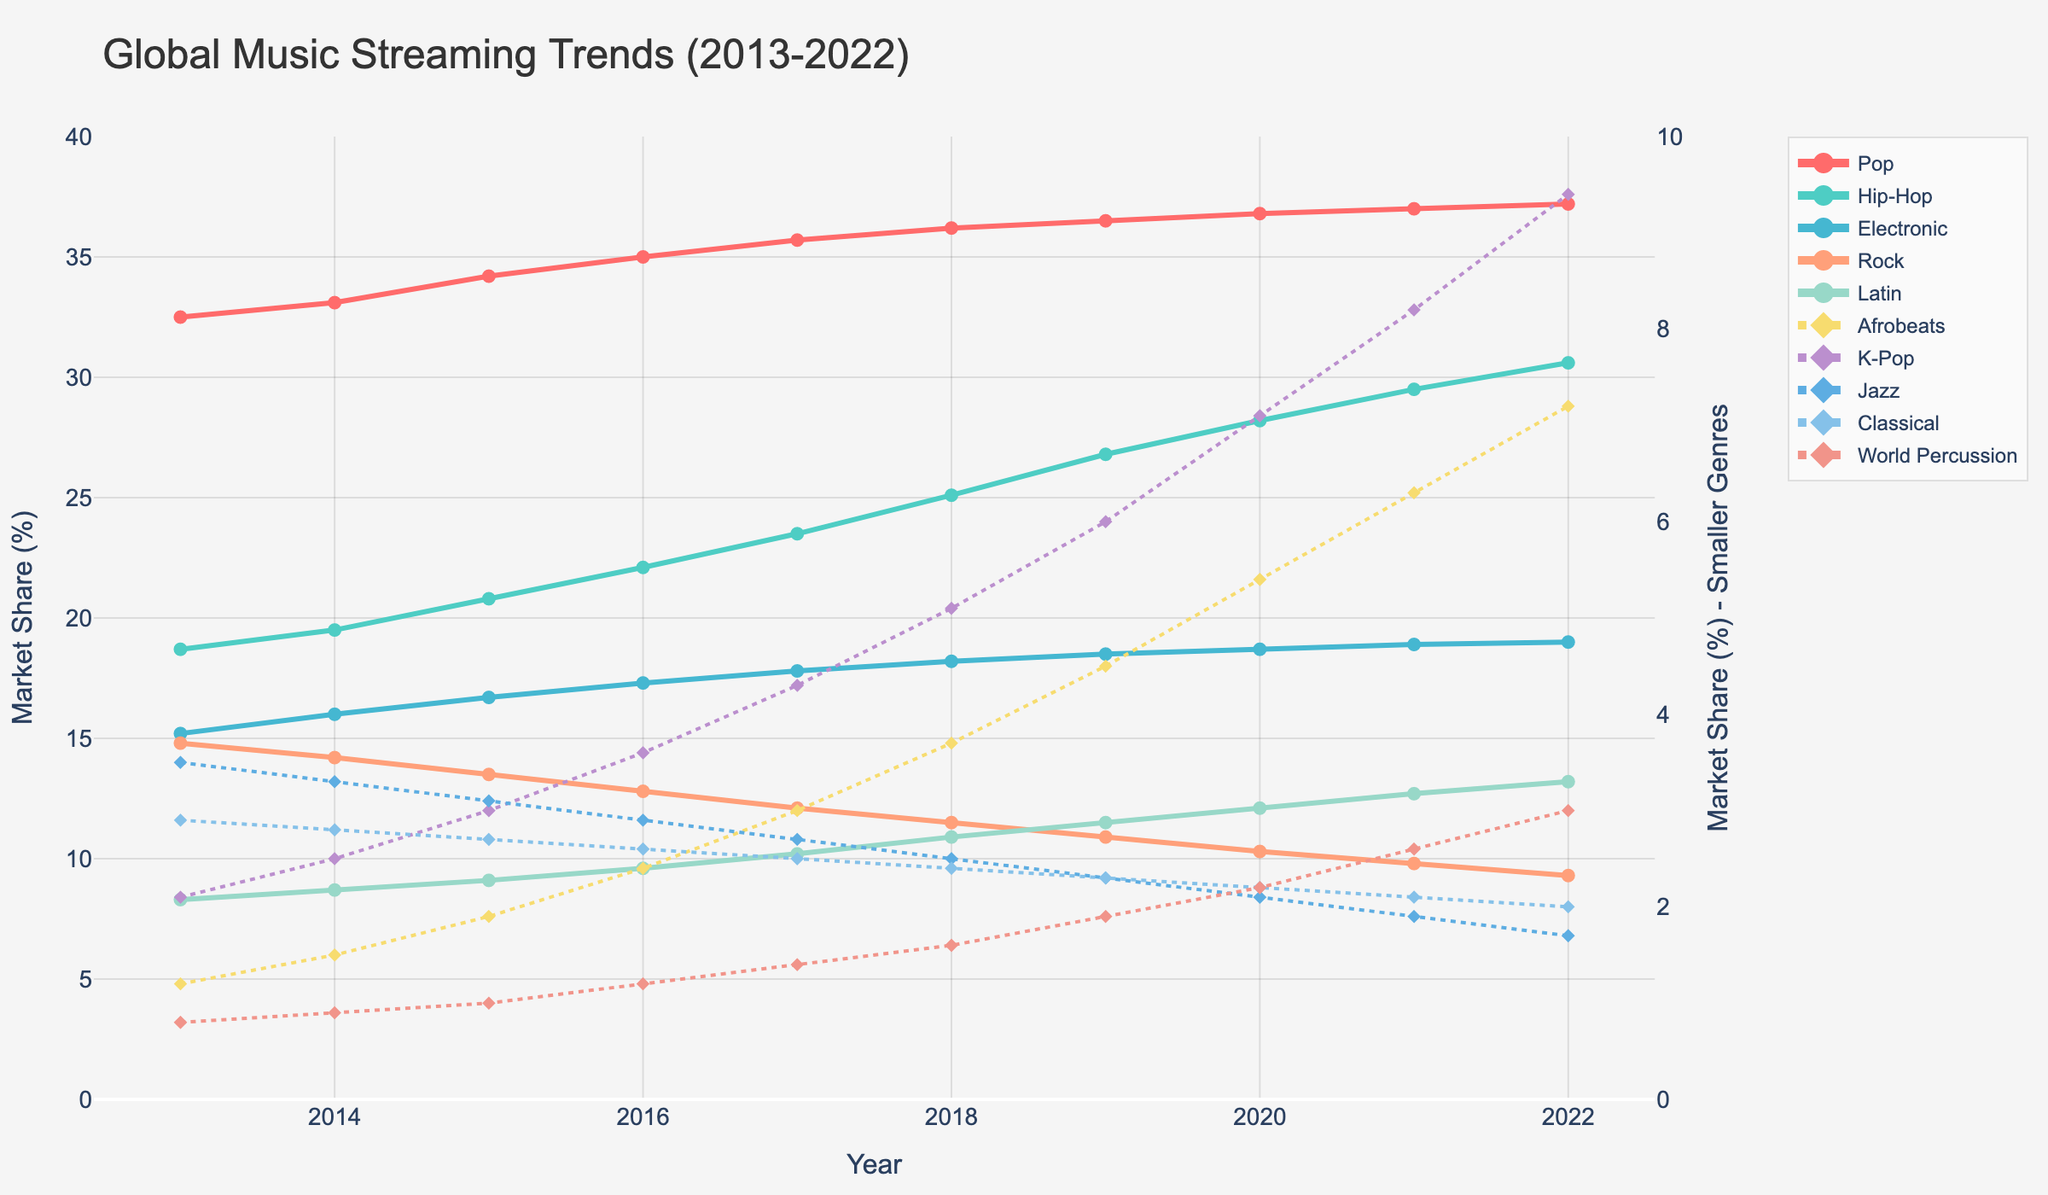What genre had the highest market share in 2022? To find this, look for the genre line that reaches the highest point on the vertical axis in the year 2022. The Pop genre line is the highest.
Answer: Pop Which genre experienced the greatest increase in market share from 2013 to 2022? Find the difference in market share for each genre between 2013 and 2022 and compare them. Hip-Hop increased from 18.7 to 30.6, an increase of 11.9, which is the highest.
Answer: Hip-Hop What is the difference in market share between Latin and Rock genres in 2020? Find the values of Latin and Rock in 2020, and calculate the difference: 12.1 - 10.3
Answer: 1.8 During which year did Hip-Hop surpass Rock in market share? Identify the year where the Hip-Hop line first crosses above the Rock line. This occurs in 2015.
Answer: 2015 What is the combined market share of Afrobeats and K-Pop in 2022? Add the market share values of Afrobeats (7.2) and K-Pop (9.4) in 2022: 7.2 + 9.4
Answer: 16.6 Between which years did Jazz see the largest decrease in market share? Examine the decrease between each consecutive year for Jazz and find the largest drop. The largest decrease is between 2020 (2.1) and 2021 (1.9), which is 0.2.
Answer: 2020 to 2021 Which genre shows a dotted line and has a market share higher than 2% in any year? Check the dotted lines representing smaller genres and identify the one exceeding 2%. World Percussion has a dotted line and crosses 2% in 2020.
Answer: World Percussion What was the market share of Electronic music in 2015, and how does it compare to 2022? The market share for Electronic in 2015 was 16.7 and in 2022 it was 19.0. Compare both values: 19.0 - 16.7
Answer: 2.3 What is the average market share of Rock between 2013 and 2022? Add up the market shares of Rock for each year and divide by the number of years: (14.8 + 14.2 + 13.5 + 12.8 + 12.1 + 11.5 + 10.9 + 10.3 + 9.8 + 9.3) / 10
Answer: 11.9 In what year did the Pop genre reach 37.0% market share for the first time? Look for the first year where the Pop genre hits 37.0% on the line chart, which happens in 2021.
Answer: 2021 